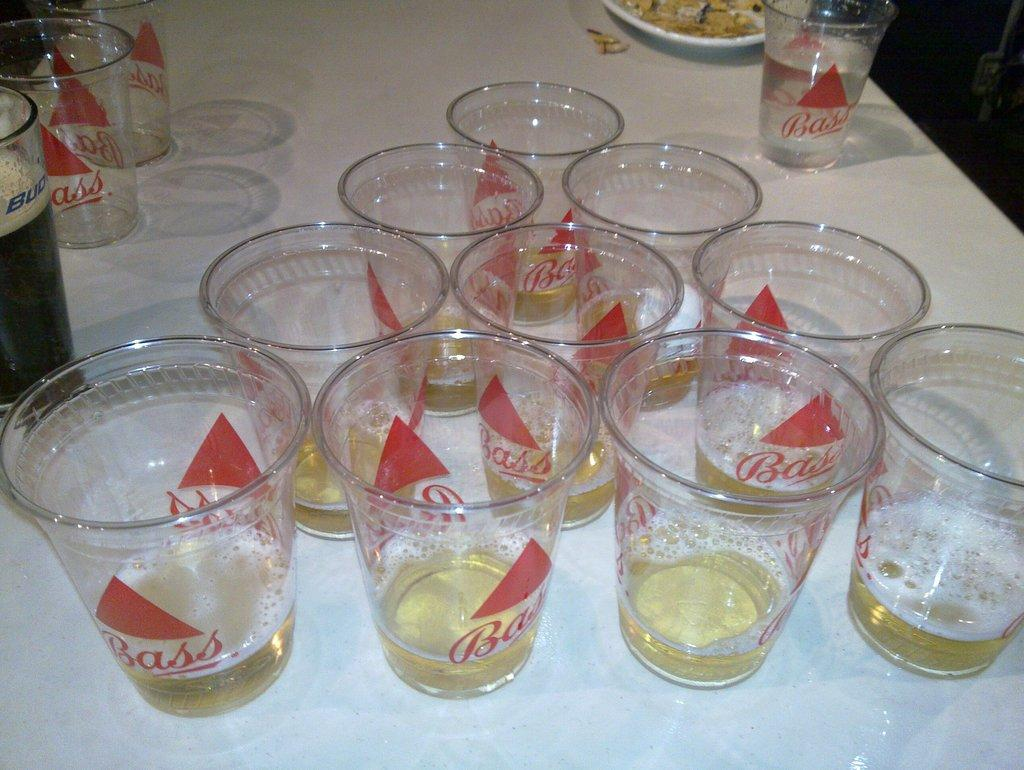What type of beverage is in the glasses in the image? There is wine in the glasses in the image. What else can be seen on the table in the image? There is a plate with food and a glass with a black-colored drink in the image. Are there any dinosaurs visible in the image? No, there are no dinosaurs present in the image. Can you see a mountain in the background of the image? No, there is no mountain visible in the image. 